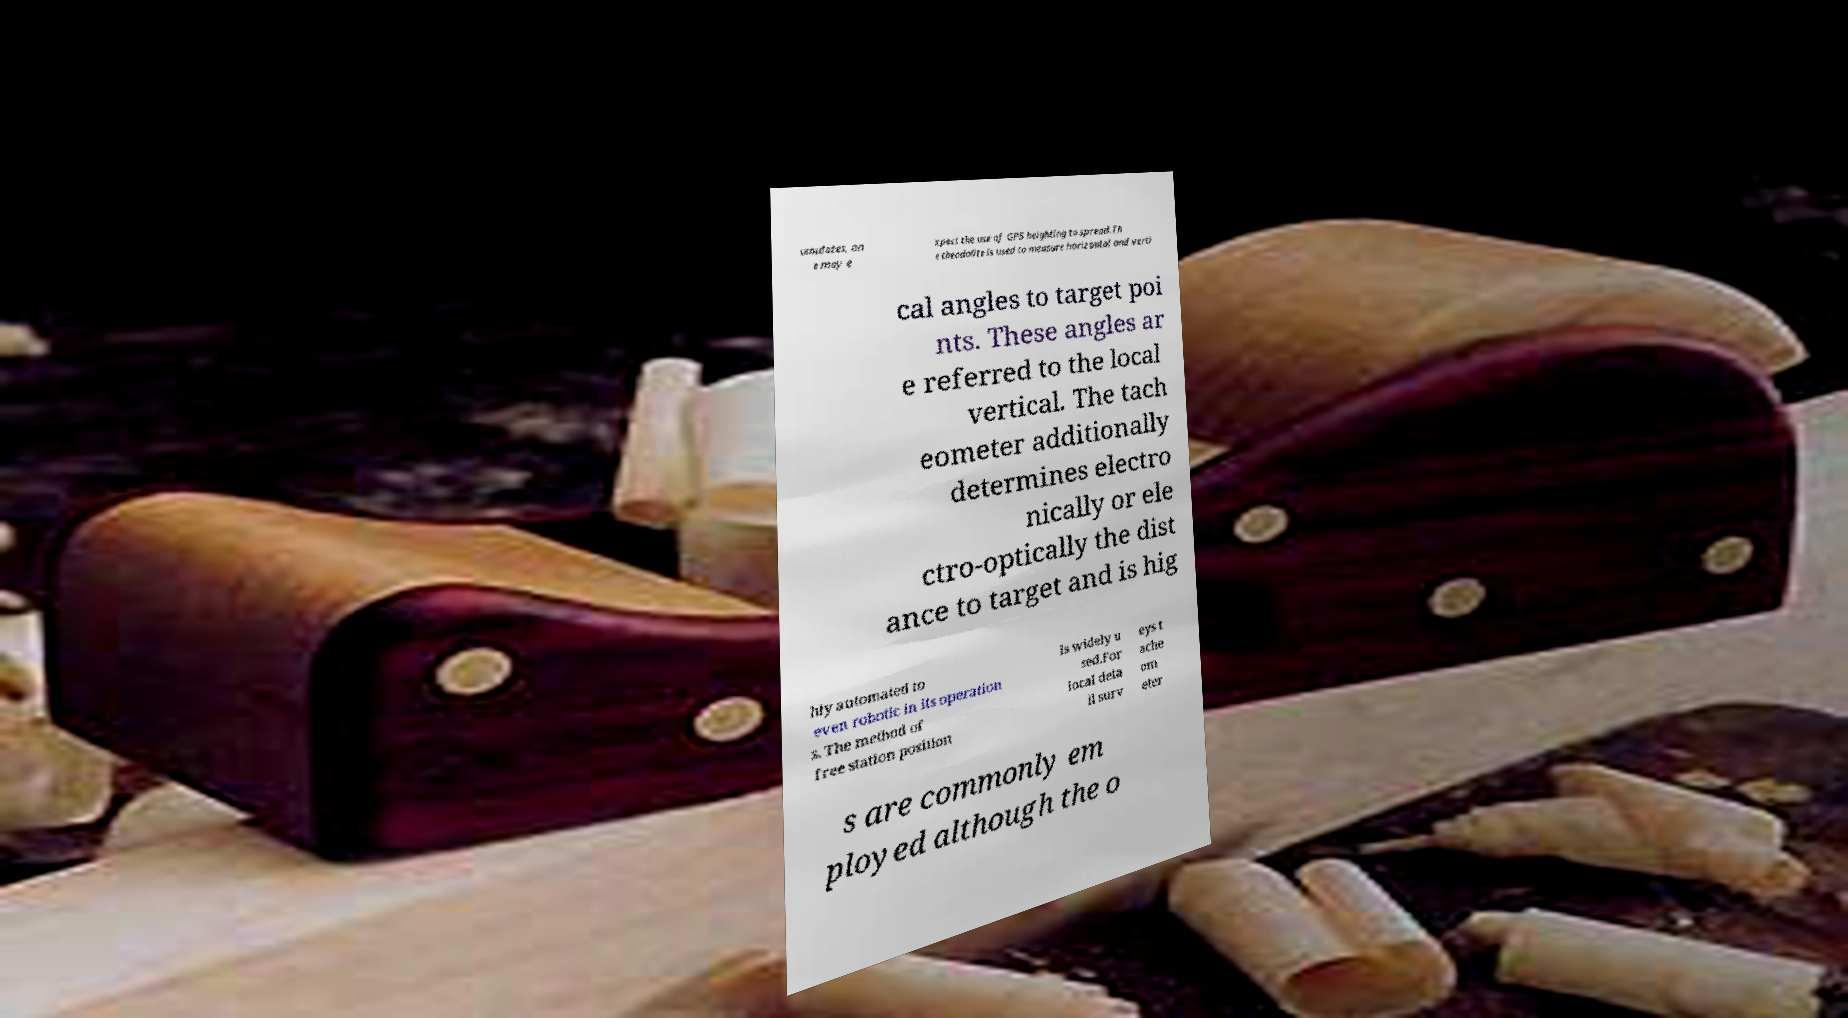Could you extract and type out the text from this image? umulates, on e may e xpect the use of GPS heighting to spread.Th e theodolite is used to measure horizontal and verti cal angles to target poi nts. These angles ar e referred to the local vertical. The tach eometer additionally determines electro nically or ele ctro-optically the dist ance to target and is hig hly automated to even robotic in its operation s. The method of free station position is widely u sed.For local deta il surv eys t ache om eter s are commonly em ployed although the o 